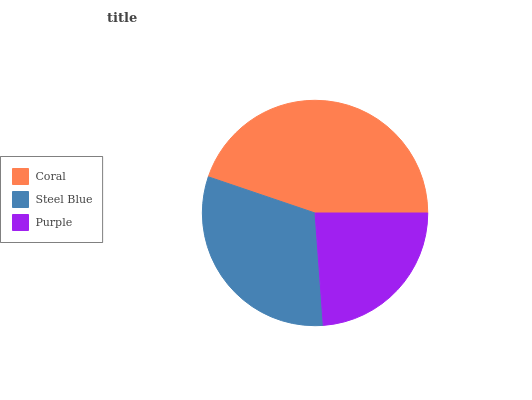Is Purple the minimum?
Answer yes or no. Yes. Is Coral the maximum?
Answer yes or no. Yes. Is Steel Blue the minimum?
Answer yes or no. No. Is Steel Blue the maximum?
Answer yes or no. No. Is Coral greater than Steel Blue?
Answer yes or no. Yes. Is Steel Blue less than Coral?
Answer yes or no. Yes. Is Steel Blue greater than Coral?
Answer yes or no. No. Is Coral less than Steel Blue?
Answer yes or no. No. Is Steel Blue the high median?
Answer yes or no. Yes. Is Steel Blue the low median?
Answer yes or no. Yes. Is Coral the high median?
Answer yes or no. No. Is Coral the low median?
Answer yes or no. No. 